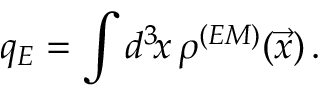Convert formula to latex. <formula><loc_0><loc_0><loc_500><loc_500>q _ { E } = \int d ^ { 3 } \, x \, \rho ^ { ( E M ) } ( \vec { x } ) \, .</formula> 